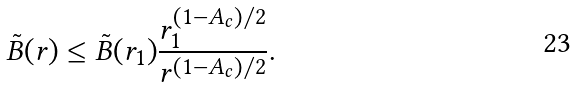<formula> <loc_0><loc_0><loc_500><loc_500>\tilde { B } ( r ) \leq \tilde { B } ( r _ { 1 } ) \frac { r _ { 1 } ^ { ( 1 - A _ { c } ) / 2 } } { r ^ { ( 1 - A _ { c } ) / 2 } } .</formula> 